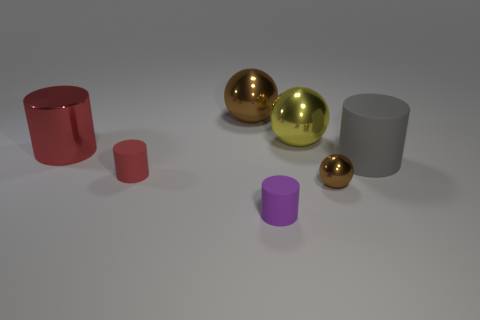There is another thing that is the same color as the small shiny object; what size is it?
Your answer should be compact. Large. Is there a big yellow shiny object of the same shape as the small purple rubber thing?
Your response must be concise. No. What is the color of the ball that is the same size as the purple cylinder?
Offer a terse response. Brown. Is the number of tiny purple things on the left side of the small purple cylinder less than the number of red metal cylinders that are in front of the big gray cylinder?
Provide a succinct answer. No. Does the brown metal object left of the purple matte cylinder have the same size as the gray matte cylinder?
Keep it short and to the point. Yes. What is the shape of the brown metallic thing that is left of the yellow metal ball?
Your answer should be very brief. Sphere. Is the number of tiny cylinders greater than the number of brown matte blocks?
Give a very brief answer. Yes. Is the color of the tiny matte cylinder that is right of the red matte thing the same as the tiny metal thing?
Provide a succinct answer. No. How many things are either large things that are to the right of the small metal ball or large cylinders on the right side of the large brown ball?
Your answer should be very brief. 1. What number of balls are behind the big red cylinder and to the right of the big yellow sphere?
Give a very brief answer. 0. 